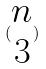Convert formula to latex. <formula><loc_0><loc_0><loc_500><loc_500>( \begin{matrix} n \\ 3 \end{matrix} )</formula> 